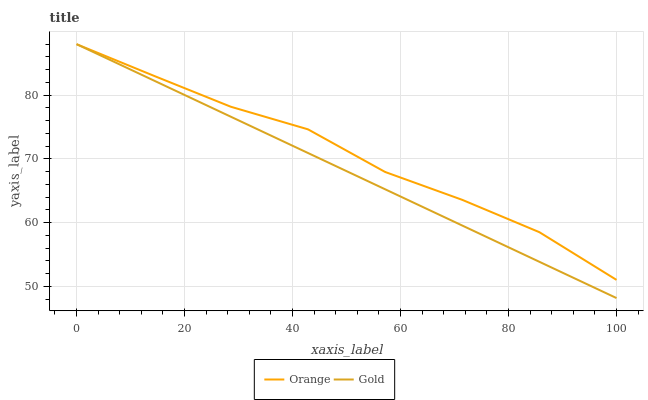Does Gold have the minimum area under the curve?
Answer yes or no. Yes. Does Orange have the maximum area under the curve?
Answer yes or no. Yes. Does Gold have the maximum area under the curve?
Answer yes or no. No. Is Gold the smoothest?
Answer yes or no. Yes. Is Orange the roughest?
Answer yes or no. Yes. Is Gold the roughest?
Answer yes or no. No. Does Gold have the lowest value?
Answer yes or no. Yes. Does Gold have the highest value?
Answer yes or no. Yes. Does Orange intersect Gold?
Answer yes or no. Yes. Is Orange less than Gold?
Answer yes or no. No. Is Orange greater than Gold?
Answer yes or no. No. 